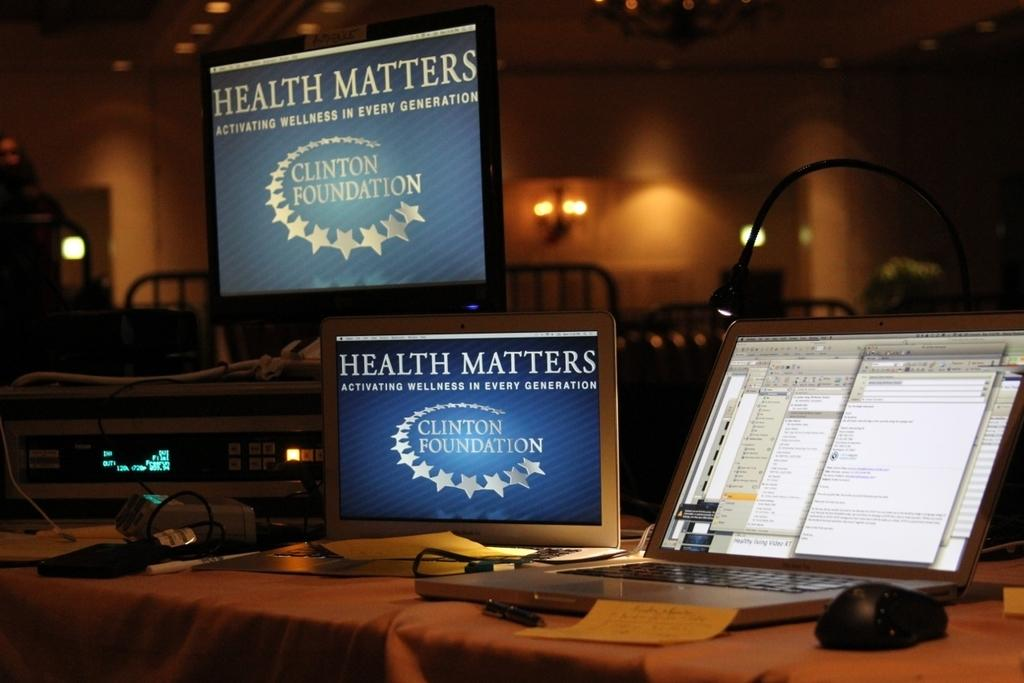<image>
Create a compact narrative representing the image presented. Health matters is displayed on monitors next to a laptop. 